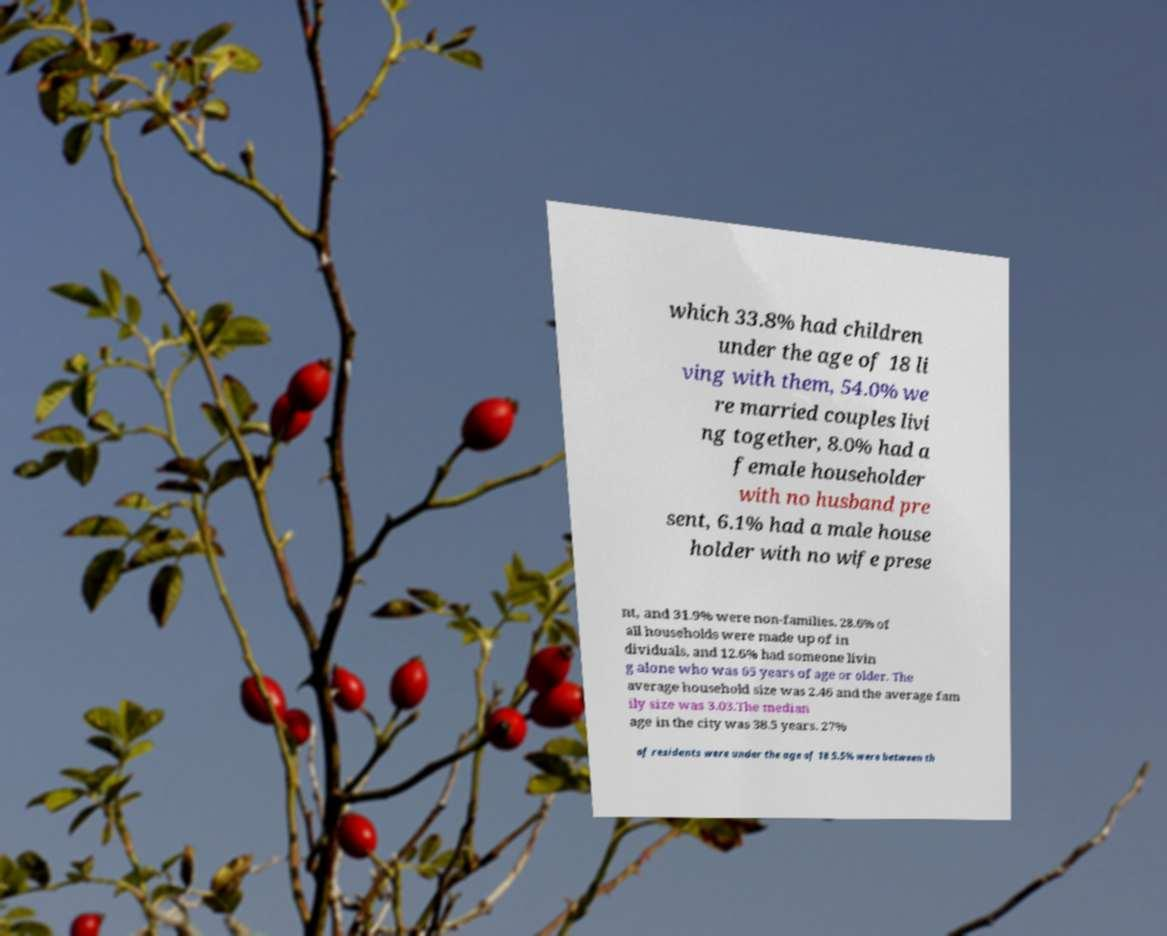There's text embedded in this image that I need extracted. Can you transcribe it verbatim? which 33.8% had children under the age of 18 li ving with them, 54.0% we re married couples livi ng together, 8.0% had a female householder with no husband pre sent, 6.1% had a male house holder with no wife prese nt, and 31.9% were non-families. 28.6% of all households were made up of in dividuals, and 12.6% had someone livin g alone who was 65 years of age or older. The average household size was 2.46 and the average fam ily size was 3.03.The median age in the city was 38.5 years. 27% of residents were under the age of 18 5.5% were between th 